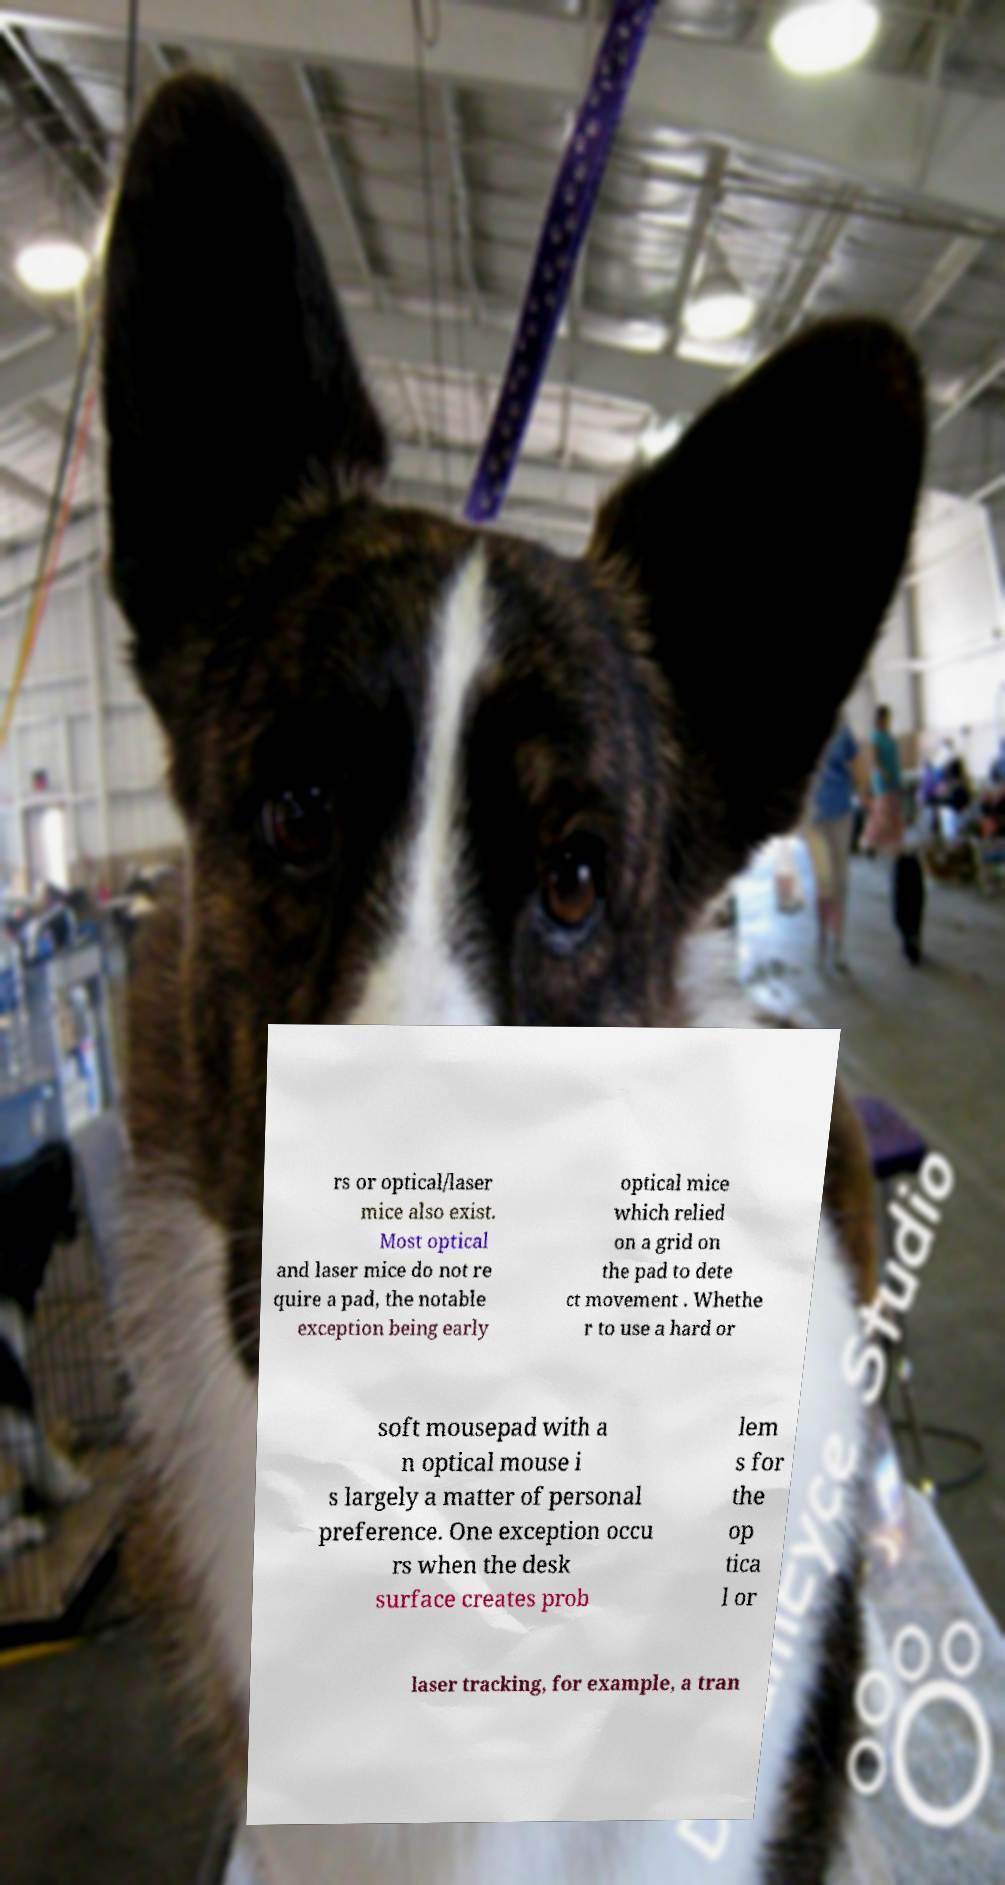Can you read and provide the text displayed in the image?This photo seems to have some interesting text. Can you extract and type it out for me? rs or optical/laser mice also exist. Most optical and laser mice do not re quire a pad, the notable exception being early optical mice which relied on a grid on the pad to dete ct movement . Whethe r to use a hard or soft mousepad with a n optical mouse i s largely a matter of personal preference. One exception occu rs when the desk surface creates prob lem s for the op tica l or laser tracking, for example, a tran 